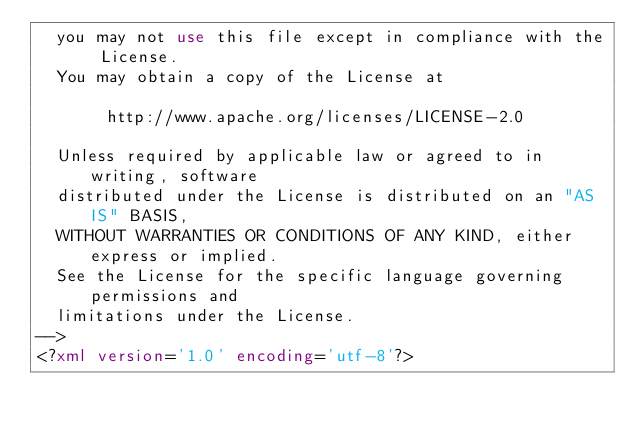Convert code to text. <code><loc_0><loc_0><loc_500><loc_500><_XML_>  you may not use this file except in compliance with the License.
  You may obtain a copy of the License at

       http://www.apache.org/licenses/LICENSE-2.0

  Unless required by applicable law or agreed to in writing, software
  distributed under the License is distributed on an "AS IS" BASIS,
  WITHOUT WARRANTIES OR CONDITIONS OF ANY KIND, either express or implied.
  See the License for the specific language governing permissions and
  limitations under the License.
-->
<?xml version='1.0' encoding='utf-8'?></code> 